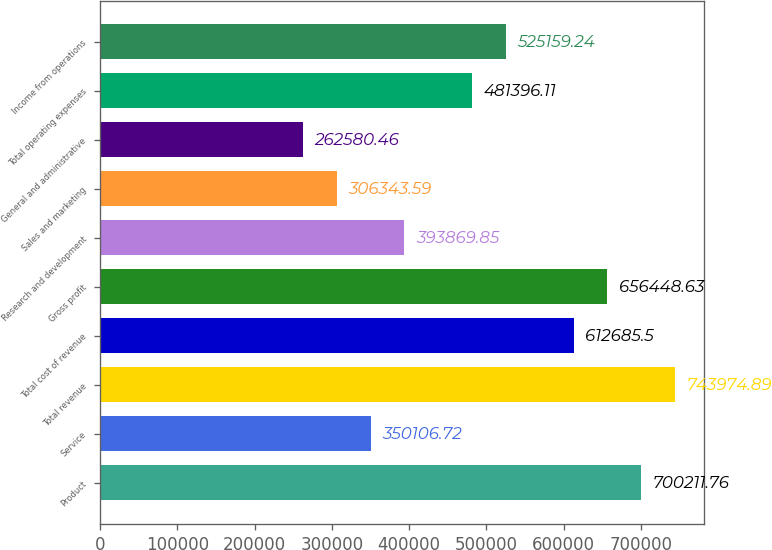<chart> <loc_0><loc_0><loc_500><loc_500><bar_chart><fcel>Product<fcel>Service<fcel>Total revenue<fcel>Total cost of revenue<fcel>Gross profit<fcel>Research and development<fcel>Sales and marketing<fcel>General and administrative<fcel>Total operating expenses<fcel>Income from operations<nl><fcel>700212<fcel>350107<fcel>743975<fcel>612686<fcel>656449<fcel>393870<fcel>306344<fcel>262580<fcel>481396<fcel>525159<nl></chart> 